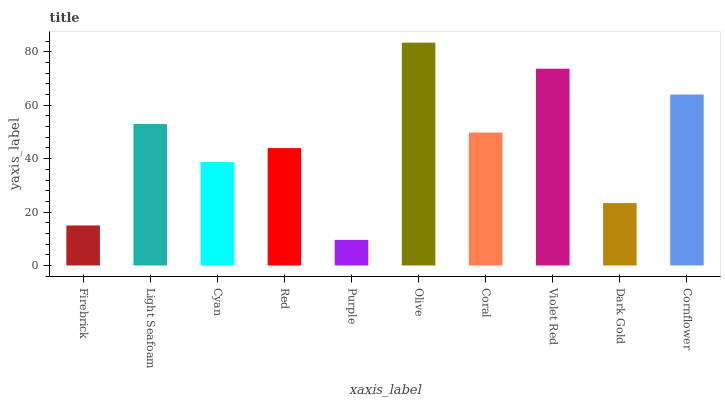Is Purple the minimum?
Answer yes or no. Yes. Is Olive the maximum?
Answer yes or no. Yes. Is Light Seafoam the minimum?
Answer yes or no. No. Is Light Seafoam the maximum?
Answer yes or no. No. Is Light Seafoam greater than Firebrick?
Answer yes or no. Yes. Is Firebrick less than Light Seafoam?
Answer yes or no. Yes. Is Firebrick greater than Light Seafoam?
Answer yes or no. No. Is Light Seafoam less than Firebrick?
Answer yes or no. No. Is Coral the high median?
Answer yes or no. Yes. Is Red the low median?
Answer yes or no. Yes. Is Cyan the high median?
Answer yes or no. No. Is Cyan the low median?
Answer yes or no. No. 